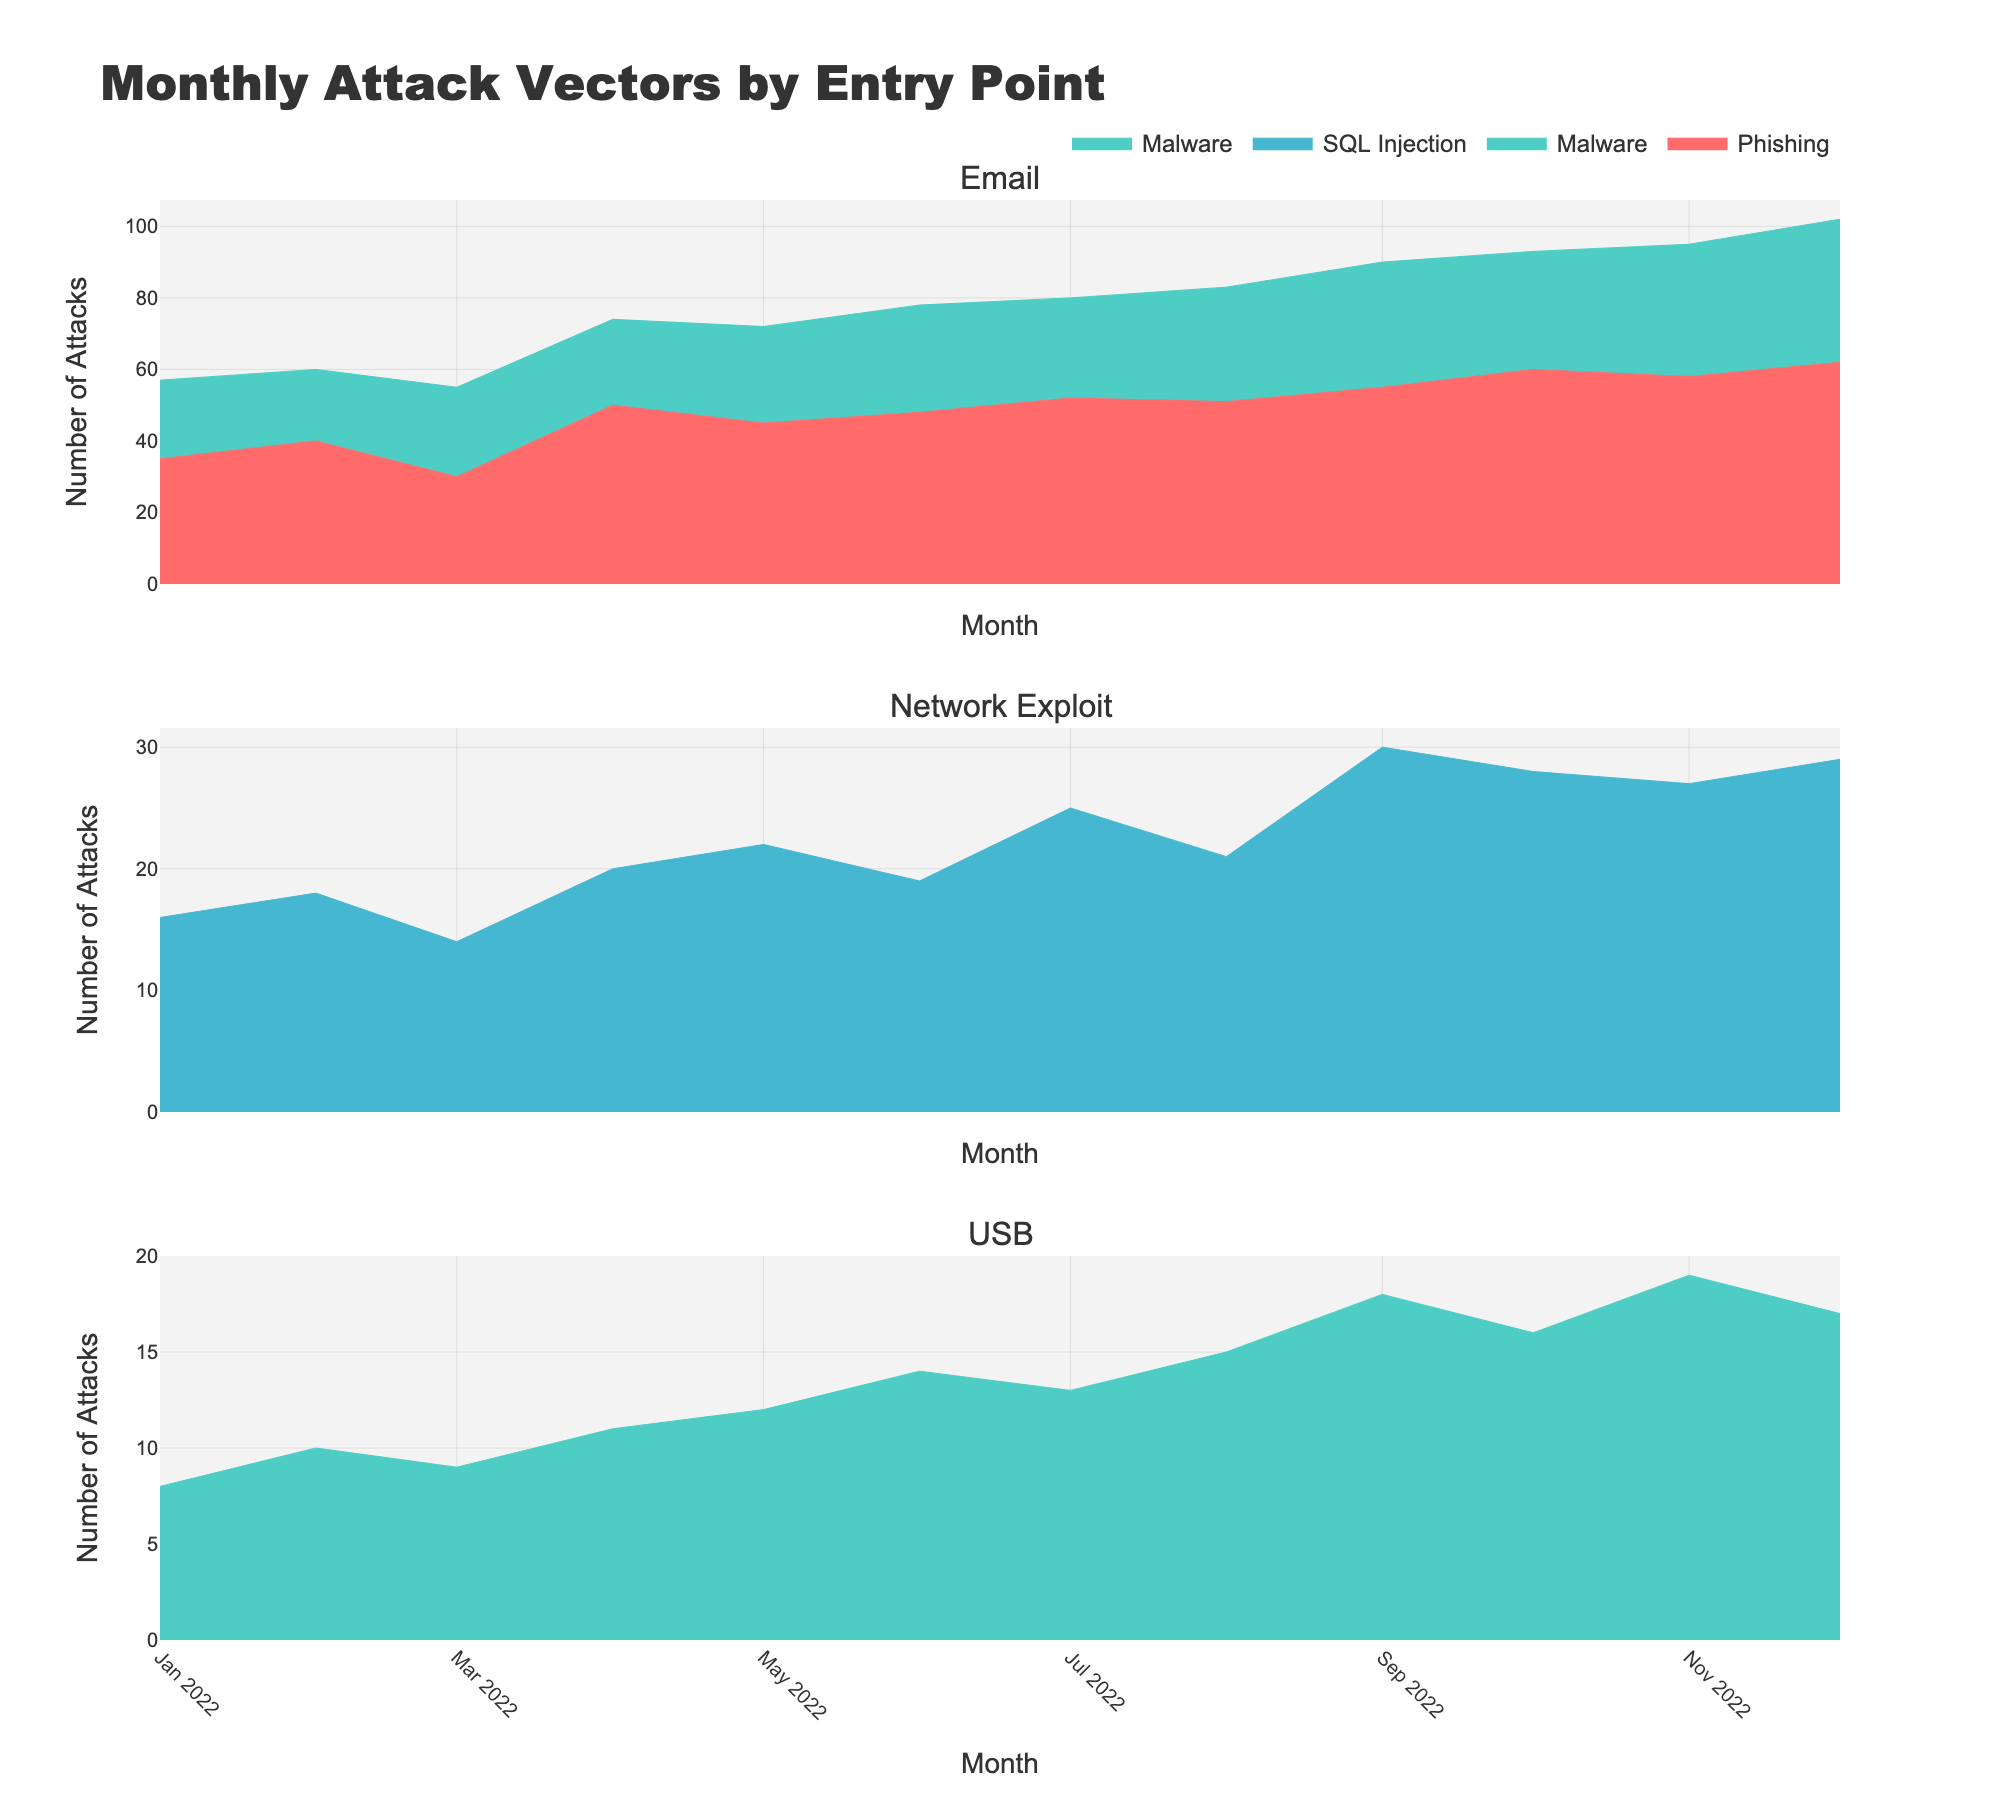Which entry point has the most variety of attack vectors? By looking at the subplots, we can see that different attack vectors are represented by different colors. The Email subplot has both Phishing and Malware, whereas Network Exploit has SQL Injection, and USB only shows Malware.
Answer: Email In which month did Email Phishing attacks peak? In the Email subplot, the line for Phishing continues to rise, and it reaches its maximum in December.
Answer: December Which entry point has the lowest total number of attacks throughout the year? By observing the area charts, USB has the smallest filled areas compared to Email and Network Exploit, indicating fewer total attacks.
Answer: USB What is the trend for Network Exploit SQL Injection attacks over the year? In the Network Exploit subplot, the area for SQL Injection generally increases, with some fluctuations, reaching high values towards the end of the year.
Answer: Increasing How do the quantities of Email Malware and Network Exploit SQL Injection compare in October? Both Email Malware and Network Exploit SQL Injection are represented in October. By observing the specific heights, Email Malware is slightly higher than Network Exploit SQL Injection.
Answer: Email Malware is higher Which attack vector showed a consistent increase over all months across any entry points? By scanning each subplot, Email Phishing is the attack vector that continuously rises each month without decline.
Answer: Email Phishing What is the total number of USB-based Malware attacks in the last quarter of the year? USB-based Malware for October, November, and December can be added: 16 (Oct) + 19 (Nov) + 17 (Dec) = 52.
Answer: 52 What month saw the highest number of combined Network Exploit and Email attacks? By viewing the Email and Network Exploit subplots, in December, both Email (Phishing and Malware) and Network Exploit (SQL Injection) are at their peaks, indicating a high total.
Answer: December Which of the entry points shows a declining trend in the final quarter of the year? By inspecting the subplots, none of the entry points show a declining trend in the last quarter; they are all either stable or increasing.
Answer: None What is the difference in the quantity of Phishing attacks between January and December for Email? From January (35) to December (62), the difference is: 62 - 35 = 27.
Answer: 27 